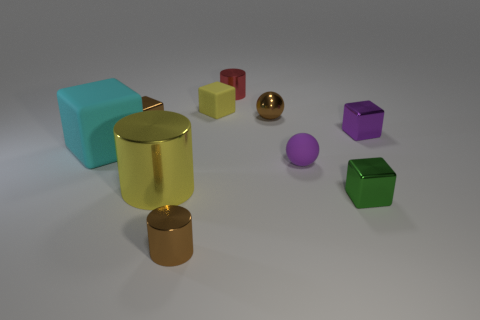Subtract 2 blocks. How many blocks are left? 3 Subtract all red cubes. Subtract all brown spheres. How many cubes are left? 5 Subtract all balls. How many objects are left? 8 Add 5 tiny brown shiny cylinders. How many tiny brown shiny cylinders are left? 6 Add 8 big yellow metallic things. How many big yellow metallic things exist? 9 Subtract 1 brown cubes. How many objects are left? 9 Subtract all tiny blue metal cylinders. Subtract all small yellow matte cubes. How many objects are left? 9 